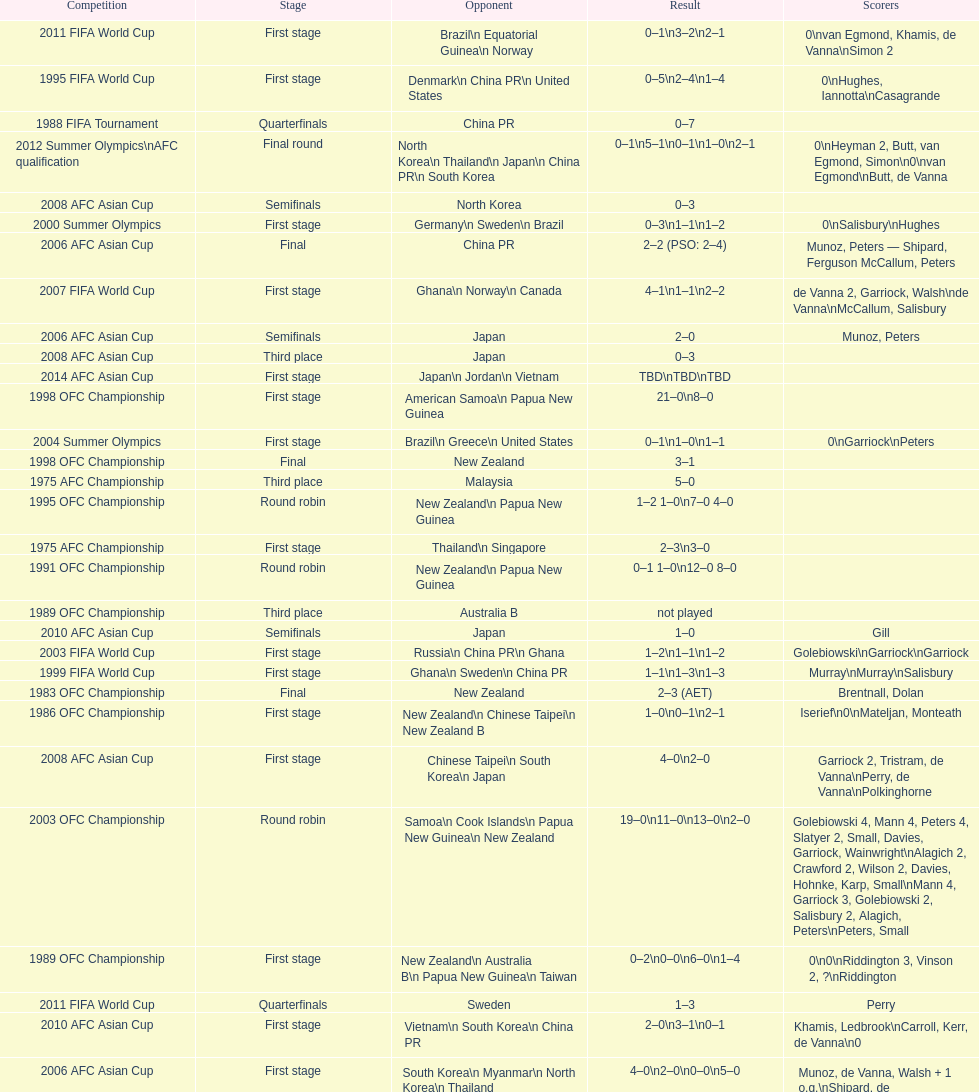Could you parse the entire table? {'header': ['Competition', 'Stage', 'Opponent', 'Result', 'Scorers'], 'rows': [['2011 FIFA World Cup', 'First stage', 'Brazil\\n\xa0Equatorial Guinea\\n\xa0Norway', '0–1\\n3–2\\n2–1', '0\\nvan Egmond, Khamis, de Vanna\\nSimon 2'], ['1995 FIFA World Cup', 'First stage', 'Denmark\\n\xa0China PR\\n\xa0United States', '0–5\\n2–4\\n1–4', '0\\nHughes, Iannotta\\nCasagrande'], ['1988 FIFA Tournament', 'Quarterfinals', 'China PR', '0–7', ''], ['2012 Summer Olympics\\nAFC qualification', 'Final round', 'North Korea\\n\xa0Thailand\\n\xa0Japan\\n\xa0China PR\\n\xa0South Korea', '0–1\\n5–1\\n0–1\\n1–0\\n2–1', '0\\nHeyman 2, Butt, van Egmond, Simon\\n0\\nvan Egmond\\nButt, de Vanna'], ['2008 AFC Asian Cup', 'Semifinals', 'North Korea', '0–3', ''], ['2000 Summer Olympics', 'First stage', 'Germany\\n\xa0Sweden\\n\xa0Brazil', '0–3\\n1–1\\n1–2', '0\\nSalisbury\\nHughes'], ['2006 AFC Asian Cup', 'Final', 'China PR', '2–2 (PSO: 2–4)', 'Munoz, Peters — Shipard, Ferguson McCallum, Peters'], ['2007 FIFA World Cup', 'First stage', 'Ghana\\n\xa0Norway\\n\xa0Canada', '4–1\\n1–1\\n2–2', 'de Vanna 2, Garriock, Walsh\\nde Vanna\\nMcCallum, Salisbury'], ['2006 AFC Asian Cup', 'Semifinals', 'Japan', '2–0', 'Munoz, Peters'], ['2008 AFC Asian Cup', 'Third place', 'Japan', '0–3', ''], ['2014 AFC Asian Cup', 'First stage', 'Japan\\n\xa0Jordan\\n\xa0Vietnam', 'TBD\\nTBD\\nTBD', ''], ['1998 OFC Championship', 'First stage', 'American Samoa\\n\xa0Papua New Guinea', '21–0\\n8–0', ''], ['2004 Summer Olympics', 'First stage', 'Brazil\\n\xa0Greece\\n\xa0United States', '0–1\\n1–0\\n1–1', '0\\nGarriock\\nPeters'], ['1998 OFC Championship', 'Final', 'New Zealand', '3–1', ''], ['1975 AFC Championship', 'Third place', 'Malaysia', '5–0', ''], ['1995 OFC Championship', 'Round robin', 'New Zealand\\n\xa0Papua New Guinea', '1–2 1–0\\n7–0 4–0', ''], ['1975 AFC Championship', 'First stage', 'Thailand\\n\xa0Singapore', '2–3\\n3–0', ''], ['1991 OFC Championship', 'Round robin', 'New Zealand\\n\xa0Papua New Guinea', '0–1 1–0\\n12–0 8–0', ''], ['1989 OFC Championship', 'Third place', 'Australia B', 'not played', ''], ['2010 AFC Asian Cup', 'Semifinals', 'Japan', '1–0', 'Gill'], ['2003 FIFA World Cup', 'First stage', 'Russia\\n\xa0China PR\\n\xa0Ghana', '1–2\\n1–1\\n1–2', 'Golebiowski\\nGarriock\\nGarriock'], ['1999 FIFA World Cup', 'First stage', 'Ghana\\n\xa0Sweden\\n\xa0China PR', '1–1\\n1–3\\n1–3', 'Murray\\nMurray\\nSalisbury'], ['1983 OFC Championship', 'Final', 'New Zealand', '2–3 (AET)', 'Brentnall, Dolan'], ['1986 OFC Championship', 'First stage', 'New Zealand\\n\xa0Chinese Taipei\\n New Zealand B', '1–0\\n0–1\\n2–1', 'Iserief\\n0\\nMateljan, Monteath'], ['2008 AFC Asian Cup', 'First stage', 'Chinese Taipei\\n\xa0South Korea\\n\xa0Japan', '4–0\\n2–0', 'Garriock 2, Tristram, de Vanna\\nPerry, de Vanna\\nPolkinghorne'], ['2003 OFC Championship', 'Round robin', 'Samoa\\n\xa0Cook Islands\\n\xa0Papua New Guinea\\n\xa0New Zealand', '19–0\\n11–0\\n13–0\\n2–0', 'Golebiowski 4, Mann 4, Peters 4, Slatyer 2, Small, Davies, Garriock, Wainwright\\nAlagich 2, Crawford 2, Wilson 2, Davies, Hohnke, Karp, Small\\nMann 4, Garriock 3, Golebiowski 2, Salisbury 2, Alagich, Peters\\nPeters, Small'], ['1989 OFC Championship', 'First stage', 'New Zealand\\n Australia B\\n\xa0Papua New Guinea\\n\xa0Taiwan', '0–2\\n0–0\\n6–0\\n1–4', '0\\n0\\nRiddington 3, Vinson 2,\xa0?\\nRiddington'], ['2011 FIFA World Cup', 'Quarterfinals', 'Sweden', '1–3', 'Perry'], ['2010 AFC Asian Cup', 'First stage', 'Vietnam\\n\xa0South Korea\\n\xa0China PR', '2–0\\n3–1\\n0–1', 'Khamis, Ledbrook\\nCarroll, Kerr, de Vanna\\n0'], ['2006 AFC Asian Cup', 'First stage', 'South Korea\\n\xa0Myanmar\\n\xa0North Korea\\n\xa0Thailand', '4–0\\n2–0\\n0–0\\n5–0', 'Munoz, de Vanna, Walsh + 1 o.g.\\nShipard, de Vanna\\n0\\nBurgess, Ferguson, Gill, de Vanna, Walsh'], ['2004 Summer Olympics', 'Quarterfinals', 'Sweden', '1–2', 'de Vanna'], ['1988 FIFA Tournament', 'First stage', 'Brazil\\n\xa0Thailand\\n\xa0Norway', '1–0\\n3–0\\n0–3', ''], ['1975 AFC Championship', 'Semifinals', 'New Zealand', '2–3', ''], ['2010 AFC Asian Cup', 'Final', 'North Korea', '1–1 (PSO: 5–4)', 'Kerr — PSO: Shipard, Ledbrook, Gill, Garriock, Simon'], ['1983 OFC Championship', 'First stage', 'New Zealand\\n\xa0New Caledonia\\n\xa0Fiji', '0–0\\n5–0\\n13–0', '0\\nDolan 2, Heydon, Porter, Wardell\\nIserief 3, Monteath 3, Heydon 3, Wardell 3, Millman'], ['2007 FIFA World Cup', 'Quarterfinals', 'Brazil', '2–3', 'Colthorpe, de Vanna'], ['1986 OFC Championship', 'Final', 'Chinese Taipei', '1–4', 'Martin'], ['1998 OFC Championship', 'Semifinals', 'Fiji', '17–0', '']]} Who was the last rival this team played against in the 2010 afc asian cup? North Korea. 